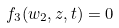Convert formula to latex. <formula><loc_0><loc_0><loc_500><loc_500>f _ { 3 } ( w _ { 2 } , z , t ) = 0</formula> 